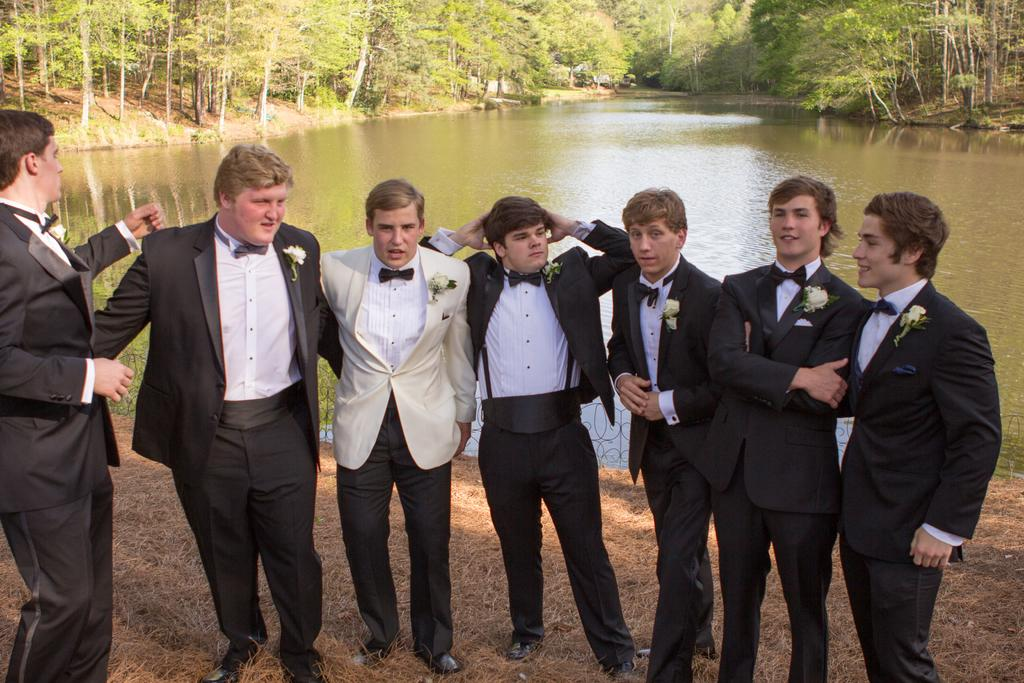What are the people in the image wearing? The people in the image are wearing suits. What are the people doing in the image? The people are standing. What type of natural environment can be seen in the image? There are trees and water visible in the image. What type of vegetation is present at the bottom of the image? Dried grass is present at the bottom of the image. What type of yak can be seen grazing in the image? There is no yak present in the image; it features people wearing suits and a natural environment with trees and water. How many bricks are visible in the image? There is no mention of bricks in the image; it focuses on people, trees, water, and dried grass. 